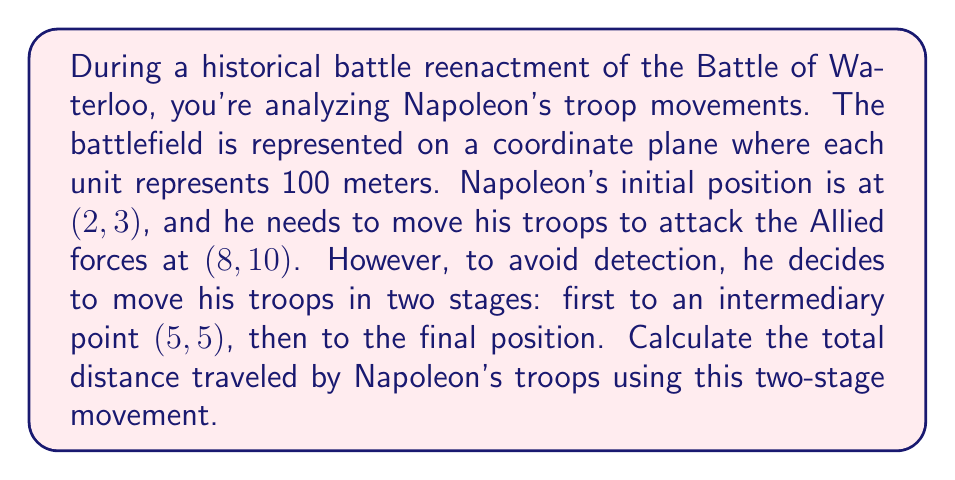Give your solution to this math problem. To solve this problem, we need to use the distance formula in a two-dimensional coordinate system. The distance formula is derived from the Pythagorean theorem:

$$ d = \sqrt{(x_2 - x_1)^2 + (y_2 - y_1)^2} $$

Where $(x_1, y_1)$ is the starting point and $(x_2, y_2)$ is the ending point.

Let's break this down into two stages:

1. From (2, 3) to (5, 5):
   $$ d_1 = \sqrt{(5 - 2)^2 + (5 - 3)^2} = \sqrt{3^2 + 2^2} = \sqrt{9 + 4} = \sqrt{13} $$

2. From (5, 5) to (8, 10):
   $$ d_2 = \sqrt{(8 - 5)^2 + (10 - 5)^2} = \sqrt{3^2 + 5^2} = \sqrt{9 + 25} = \sqrt{34} $$

The total distance is the sum of these two distances:

$$ d_{total} = d_1 + d_2 = \sqrt{13} + \sqrt{34} $$

To simplify:
$$ d_{total} = \sqrt{13} + \sqrt{34} \approx 3.61 + 5.83 \approx 9.44 $$

Remember that each unit represents 100 meters, so the actual distance in meters would be:

$$ 9.44 * 100 = 944 \text{ meters} $$
Answer: The total distance traveled by Napoleon's troops is $\sqrt{13} + \sqrt{34}$ units, or approximately 944 meters. 